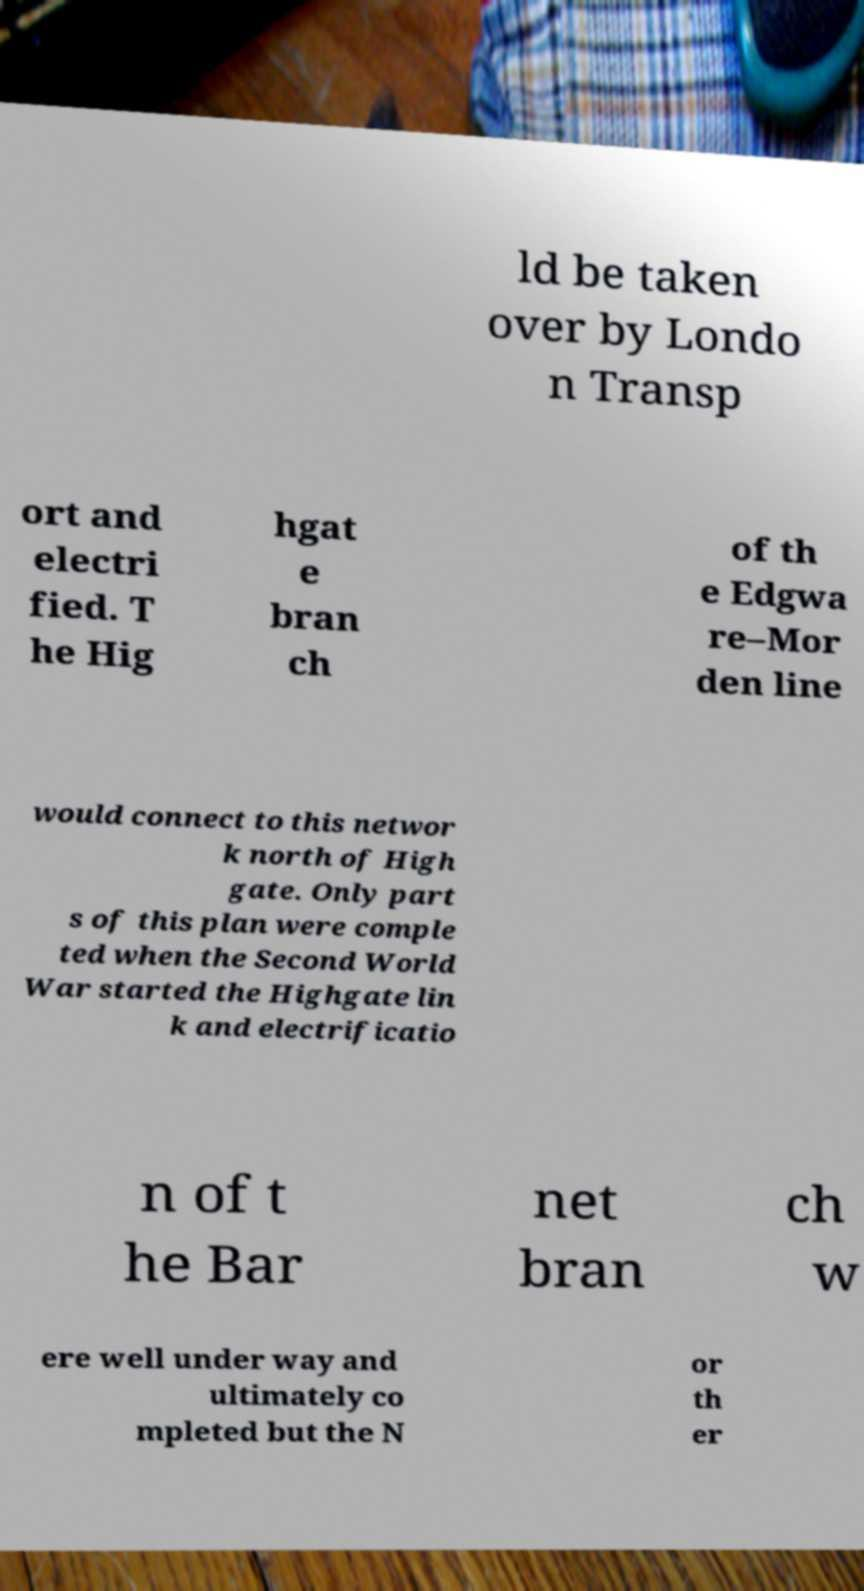Could you assist in decoding the text presented in this image and type it out clearly? ld be taken over by Londo n Transp ort and electri fied. T he Hig hgat e bran ch of th e Edgwa re–Mor den line would connect to this networ k north of High gate. Only part s of this plan were comple ted when the Second World War started the Highgate lin k and electrificatio n of t he Bar net bran ch w ere well under way and ultimately co mpleted but the N or th er 